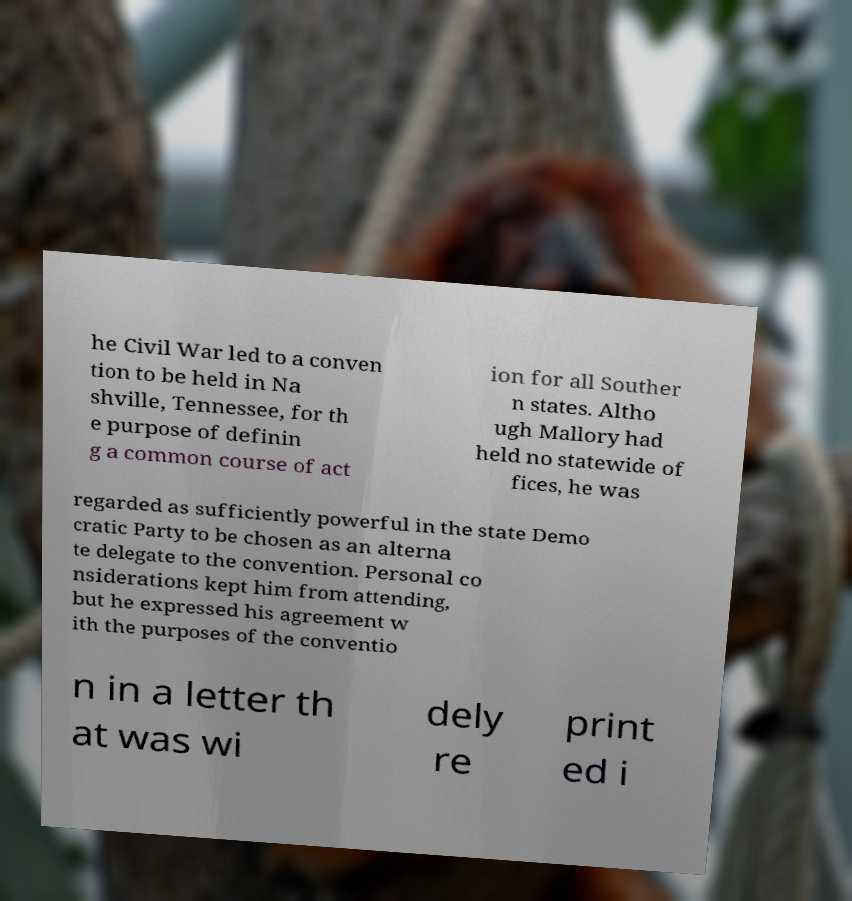Please read and relay the text visible in this image. What does it say? he Civil War led to a conven tion to be held in Na shville, Tennessee, for th e purpose of definin g a common course of act ion for all Souther n states. Altho ugh Mallory had held no statewide of fices, he was regarded as sufficiently powerful in the state Demo cratic Party to be chosen as an alterna te delegate to the convention. Personal co nsiderations kept him from attending, but he expressed his agreement w ith the purposes of the conventio n in a letter th at was wi dely re print ed i 